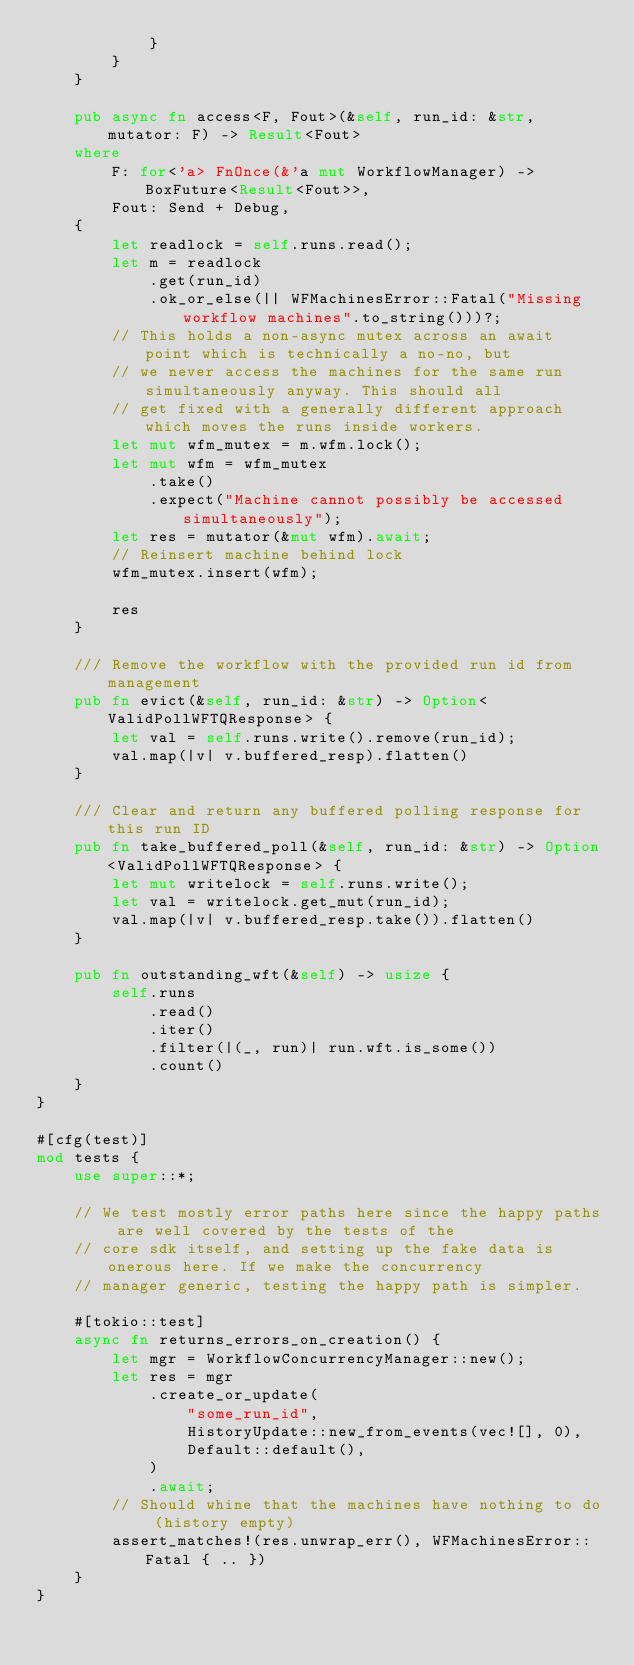<code> <loc_0><loc_0><loc_500><loc_500><_Rust_>            }
        }
    }

    pub async fn access<F, Fout>(&self, run_id: &str, mutator: F) -> Result<Fout>
    where
        F: for<'a> FnOnce(&'a mut WorkflowManager) -> BoxFuture<Result<Fout>>,
        Fout: Send + Debug,
    {
        let readlock = self.runs.read();
        let m = readlock
            .get(run_id)
            .ok_or_else(|| WFMachinesError::Fatal("Missing workflow machines".to_string()))?;
        // This holds a non-async mutex across an await point which is technically a no-no, but
        // we never access the machines for the same run simultaneously anyway. This should all
        // get fixed with a generally different approach which moves the runs inside workers.
        let mut wfm_mutex = m.wfm.lock();
        let mut wfm = wfm_mutex
            .take()
            .expect("Machine cannot possibly be accessed simultaneously");
        let res = mutator(&mut wfm).await;
        // Reinsert machine behind lock
        wfm_mutex.insert(wfm);

        res
    }

    /// Remove the workflow with the provided run id from management
    pub fn evict(&self, run_id: &str) -> Option<ValidPollWFTQResponse> {
        let val = self.runs.write().remove(run_id);
        val.map(|v| v.buffered_resp).flatten()
    }

    /// Clear and return any buffered polling response for this run ID
    pub fn take_buffered_poll(&self, run_id: &str) -> Option<ValidPollWFTQResponse> {
        let mut writelock = self.runs.write();
        let val = writelock.get_mut(run_id);
        val.map(|v| v.buffered_resp.take()).flatten()
    }

    pub fn outstanding_wft(&self) -> usize {
        self.runs
            .read()
            .iter()
            .filter(|(_, run)| run.wft.is_some())
            .count()
    }
}

#[cfg(test)]
mod tests {
    use super::*;

    // We test mostly error paths here since the happy paths are well covered by the tests of the
    // core sdk itself, and setting up the fake data is onerous here. If we make the concurrency
    // manager generic, testing the happy path is simpler.

    #[tokio::test]
    async fn returns_errors_on_creation() {
        let mgr = WorkflowConcurrencyManager::new();
        let res = mgr
            .create_or_update(
                "some_run_id",
                HistoryUpdate::new_from_events(vec![], 0),
                Default::default(),
            )
            .await;
        // Should whine that the machines have nothing to do (history empty)
        assert_matches!(res.unwrap_err(), WFMachinesError::Fatal { .. })
    }
}
</code> 